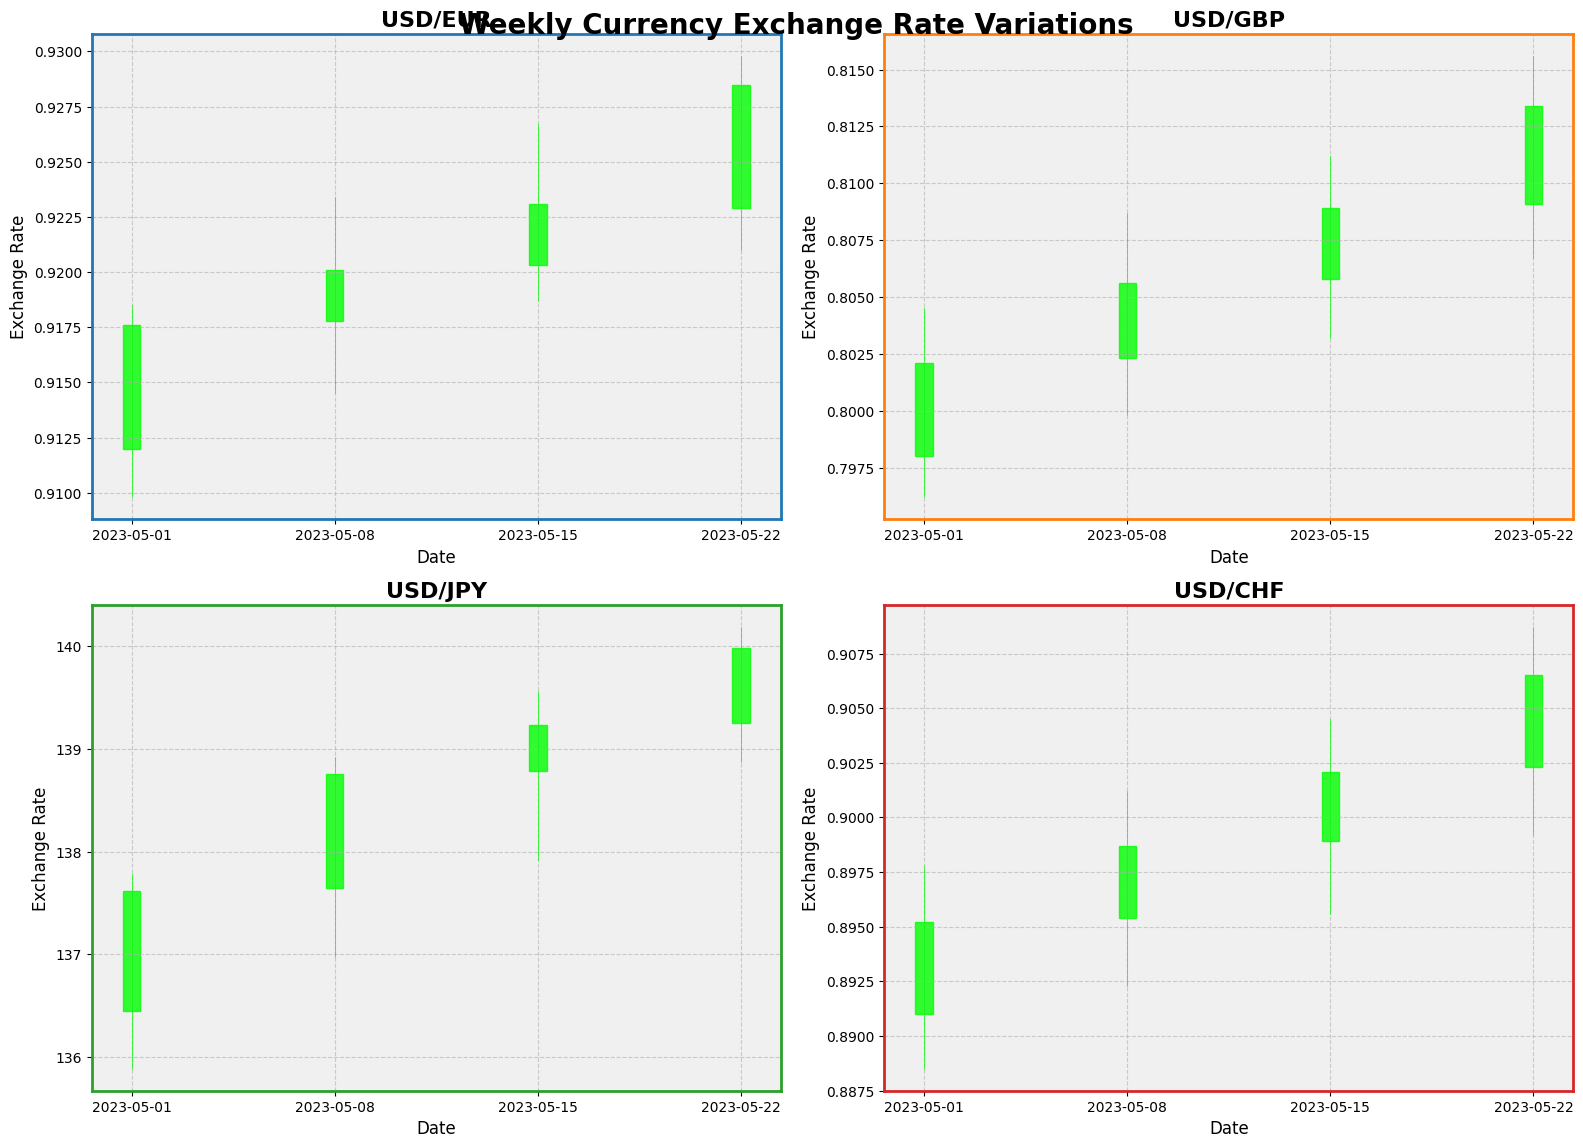What is the overall title of the figure? The overall title of the figure is visually displayed at the top center of the plot. It is prominently placed for easy identification.
Answer: Weekly Currency Exchange Rate Variations Which currency has the highest closing rate during the week of May 22, 2023? Examine all panels representing the four currencies and identify the closing rates for the week of May 22, 2023. Compare these values to find the highest one.
Answer: USD/JPY What is the difference between the highest and lowest closing rates for USD/EUR during the given period? Identify the closing rates for each week for USD/EUR. The values are 0.9176, 0.9201, 0.9231, 0.9285. Calculate the difference by subtracting the smallest value from the largest value.
Answer: 0.0109 How does the trend in USD/GBP compare to the trend in USD/CHF over the weeks? Look at the pattern of the closing rates over the weeks for both USD/GBP and USD/CHF. USD/GBP increases from 0.8021 to 0.8134, while USD/CHF increases from 0.8952 to 0.9065. Both currencies show an upward trend, but with different slopes.
Answer: Both are upward trends Which week had the lowest volatility for USD/JPY? Volatility can be observed by the range between the high and low points for each week. Compare these ranges to find the week with the smallest range.
Answer: 2023-05-15 What is the closing rate trend for USD/CHF during the given period? Observe the closing rates for each week for USD/CHF, which are 0.8952, 0.8987, 0.9021, 0.9065. Note their progression to determine the trend.
Answer: Increasing Which currency shows the most significant overall increase in closing rate over the period? Calculate the difference between the first and last closing rates for each currency and compare these values. The increases are: USD/EUR (0.9285-0.9176=0.0109), USD/GBP (0.8134-0.8021=0.0113), USD/JPY (139.98-137.62=2.36), USD/CHF (0.9065-0.8952=0.0113).
Answer: USD/JPY 